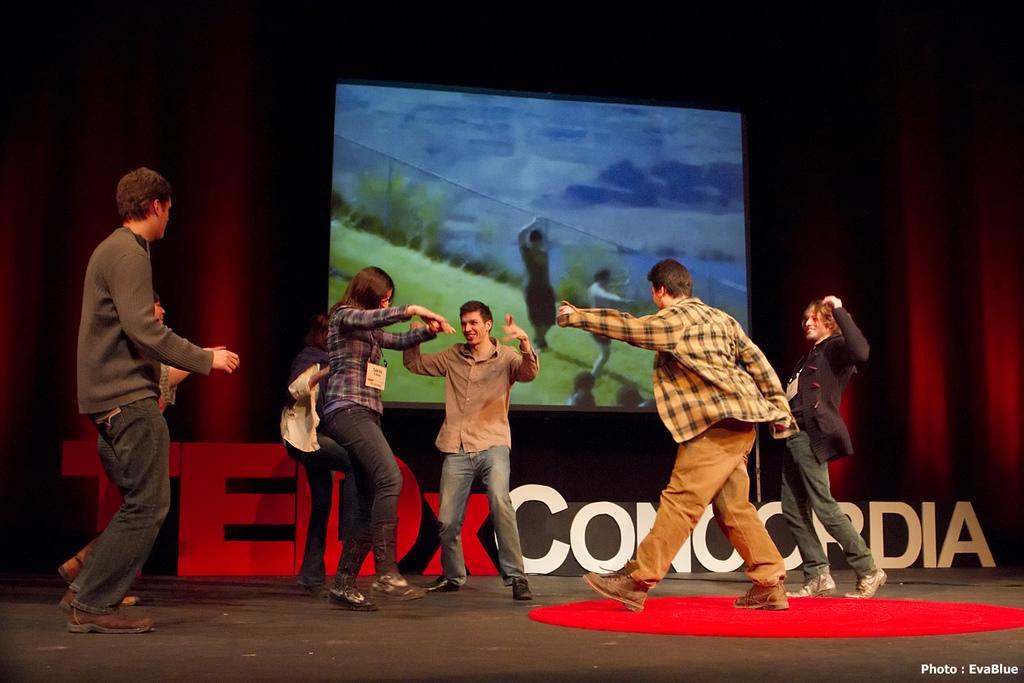Can you describe this image briefly? In this image, we can see a group of people are dancing on the floor. Here we can see a red mat. Background we can see a curtain, screen. At the bottom, we can see a watermark in the image. Here we can see two people are smiling. 